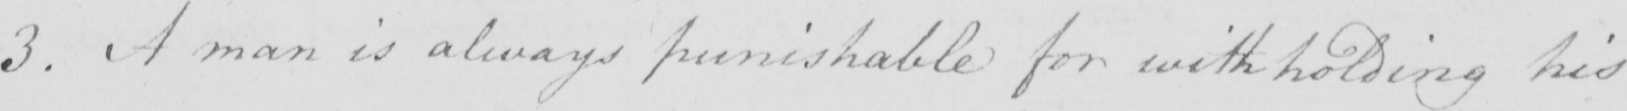Please transcribe the handwritten text in this image. 3 . A man is always punishable for withholding his 